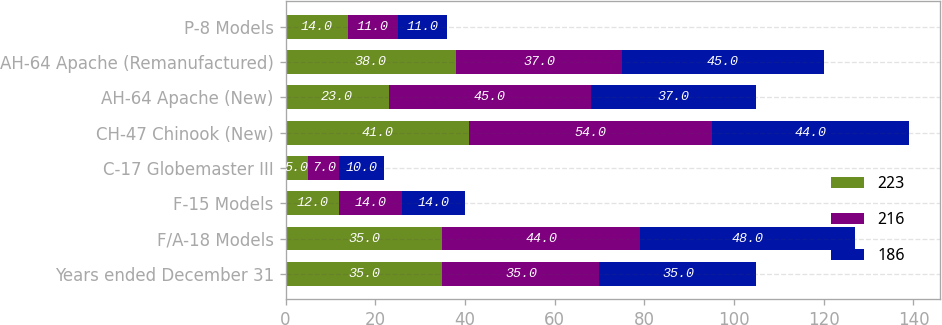Convert chart to OTSL. <chart><loc_0><loc_0><loc_500><loc_500><stacked_bar_chart><ecel><fcel>Years ended December 31<fcel>F/A-18 Models<fcel>F-15 Models<fcel>C-17 Globemaster III<fcel>CH-47 Chinook (New)<fcel>AH-64 Apache (New)<fcel>AH-64 Apache (Remanufactured)<fcel>P-8 Models<nl><fcel>223<fcel>35<fcel>35<fcel>12<fcel>5<fcel>41<fcel>23<fcel>38<fcel>14<nl><fcel>216<fcel>35<fcel>44<fcel>14<fcel>7<fcel>54<fcel>45<fcel>37<fcel>11<nl><fcel>186<fcel>35<fcel>48<fcel>14<fcel>10<fcel>44<fcel>37<fcel>45<fcel>11<nl></chart> 